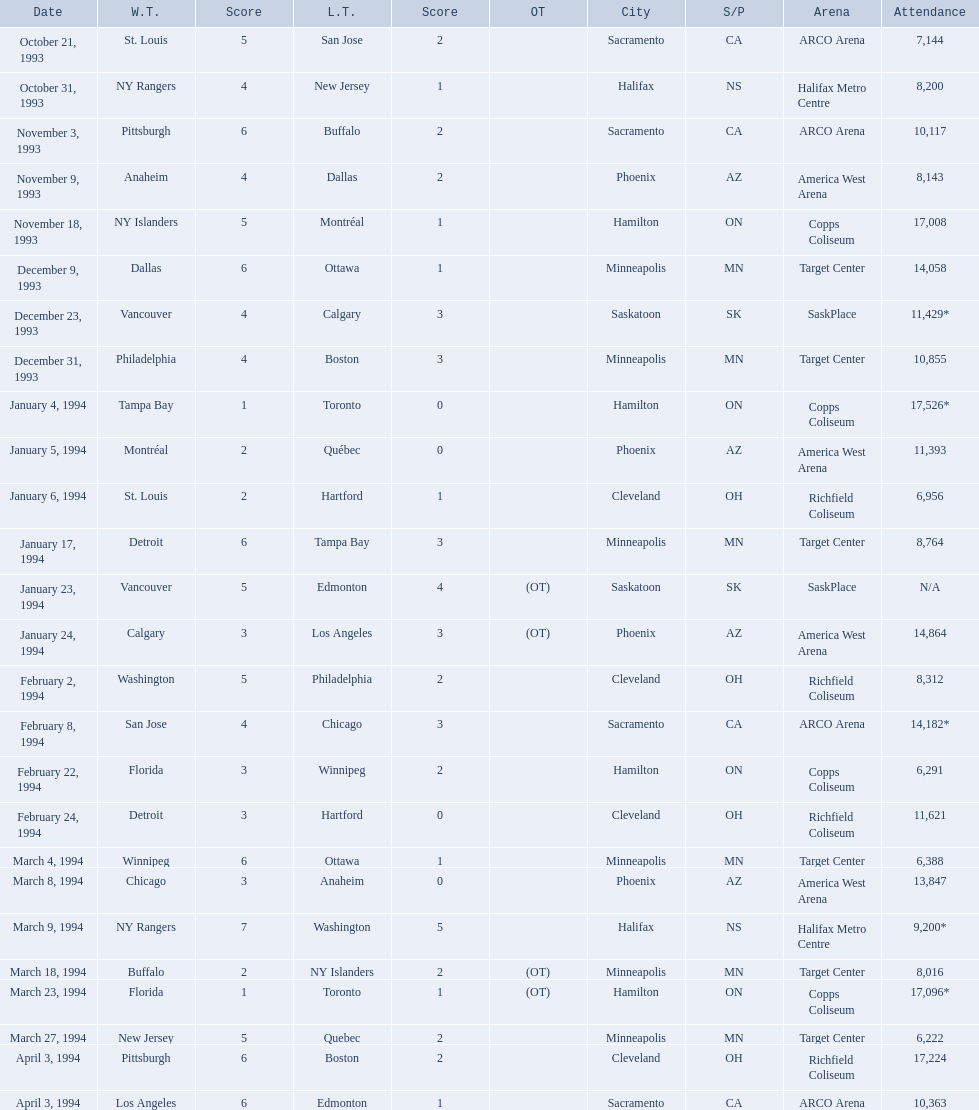When were the games played? October 21, 1993, October 31, 1993, November 3, 1993, November 9, 1993, November 18, 1993, December 9, 1993, December 23, 1993, December 31, 1993, January 4, 1994, January 5, 1994, January 6, 1994, January 17, 1994, January 23, 1994, January 24, 1994, February 2, 1994, February 8, 1994, February 22, 1994, February 24, 1994, March 4, 1994, March 8, 1994, March 9, 1994, March 18, 1994, March 23, 1994, March 27, 1994, April 3, 1994, April 3, 1994. What was the attendance for those games? 7,144, 8,200, 10,117, 8,143, 17,008, 14,058, 11,429*, 10,855, 17,526*, 11,393, 6,956, 8,764, N/A, 14,864, 8,312, 14,182*, 6,291, 11,621, 6,388, 13,847, 9,200*, 8,016, 17,096*, 6,222, 17,224, 10,363. Which date had the highest attendance? January 4, 1994. 